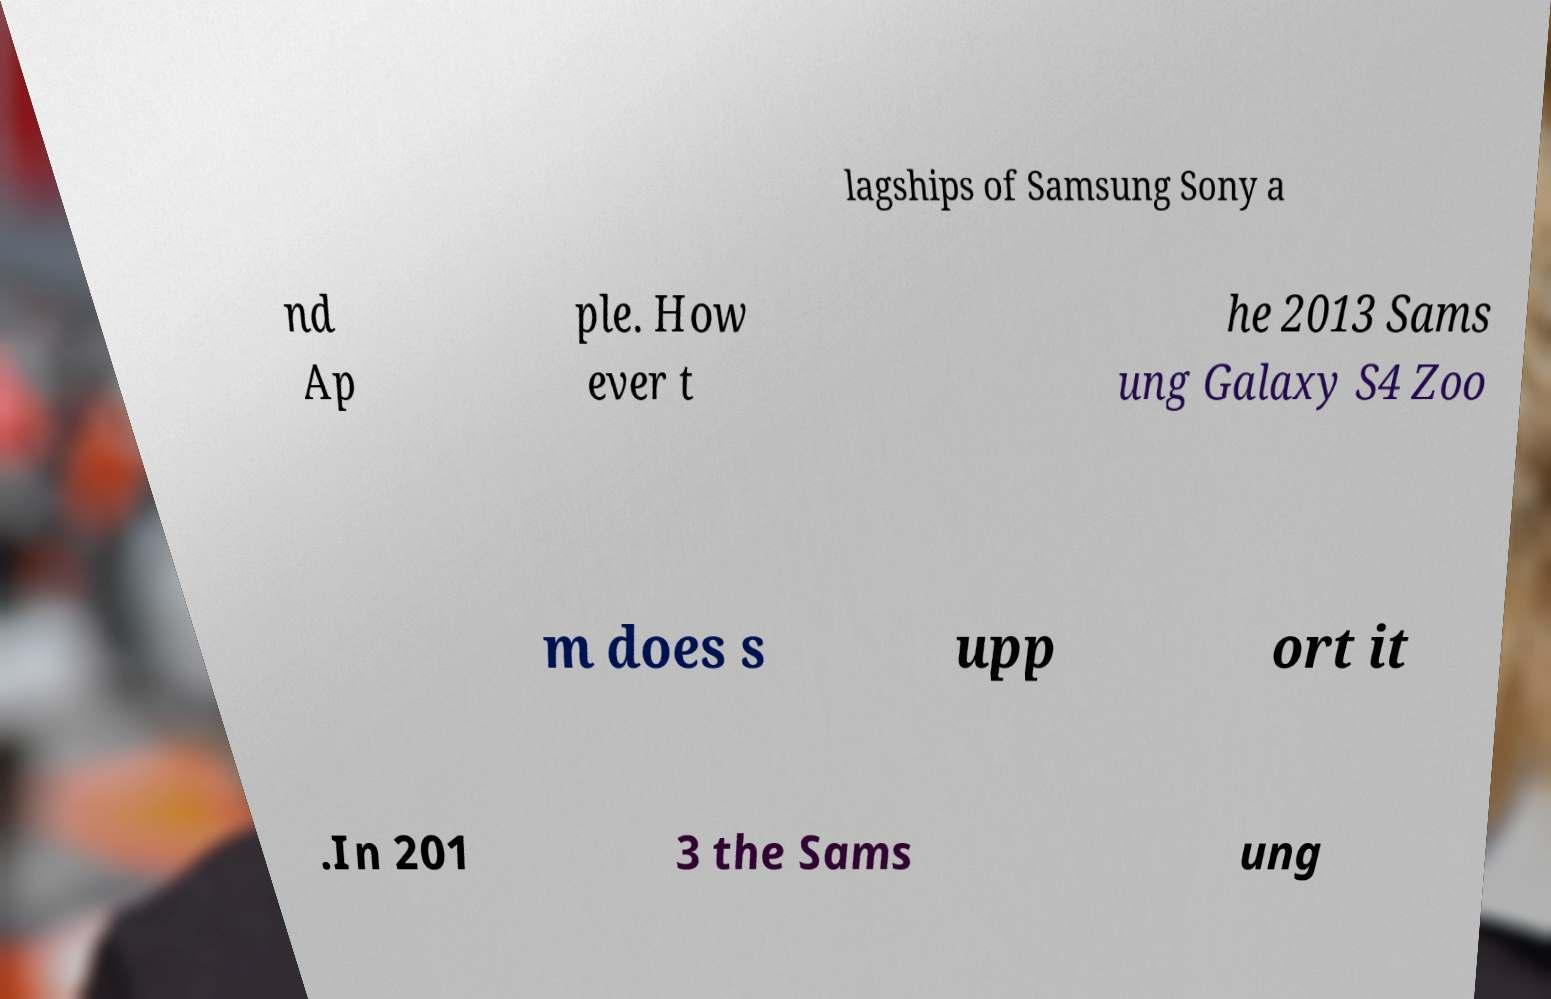Please read and relay the text visible in this image. What does it say? lagships of Samsung Sony a nd Ap ple. How ever t he 2013 Sams ung Galaxy S4 Zoo m does s upp ort it .In 201 3 the Sams ung 